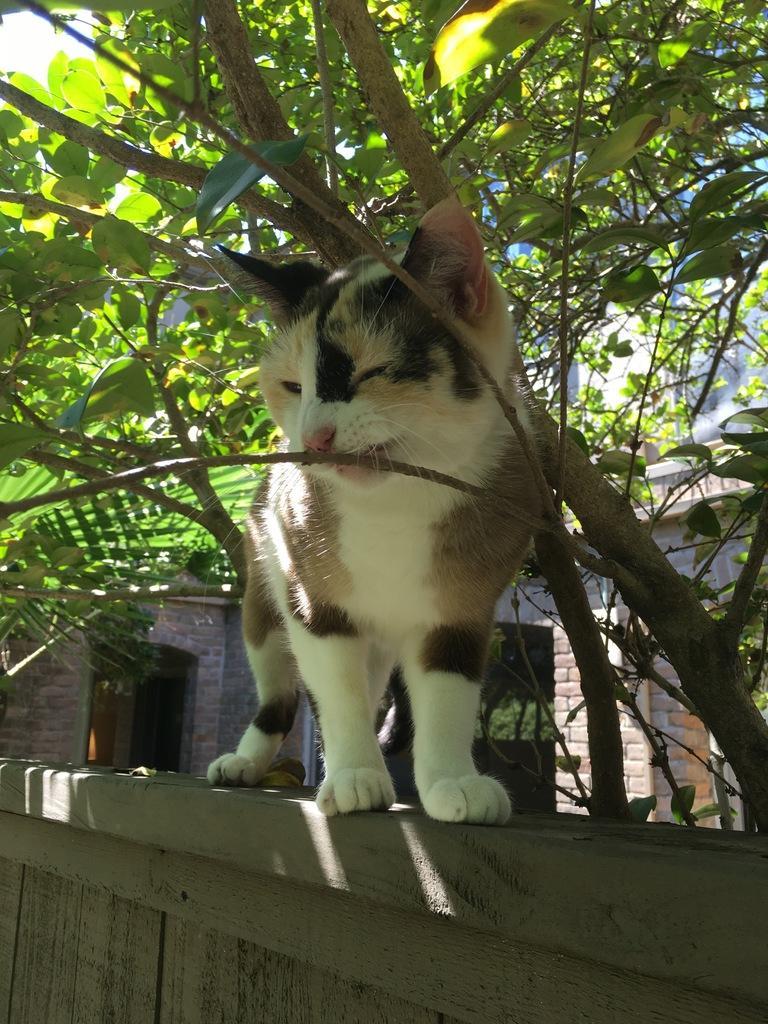Could you give a brief overview of what you see in this image? In this image, we can see a cat on the wall and in the background, there are trees and buildings. 